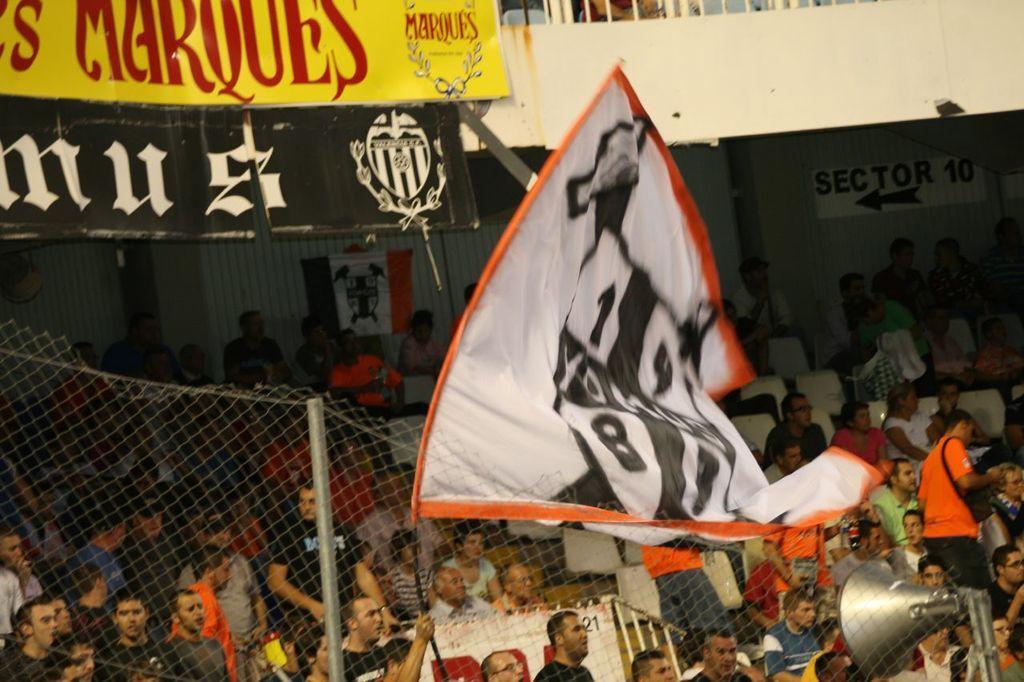Can you describe this image briefly? In this image, on the right side, we can see a microphone. In the middle of the image, we can see a flag. In the background, we can see a net fence, metal rod, group of people, board and a wall. 